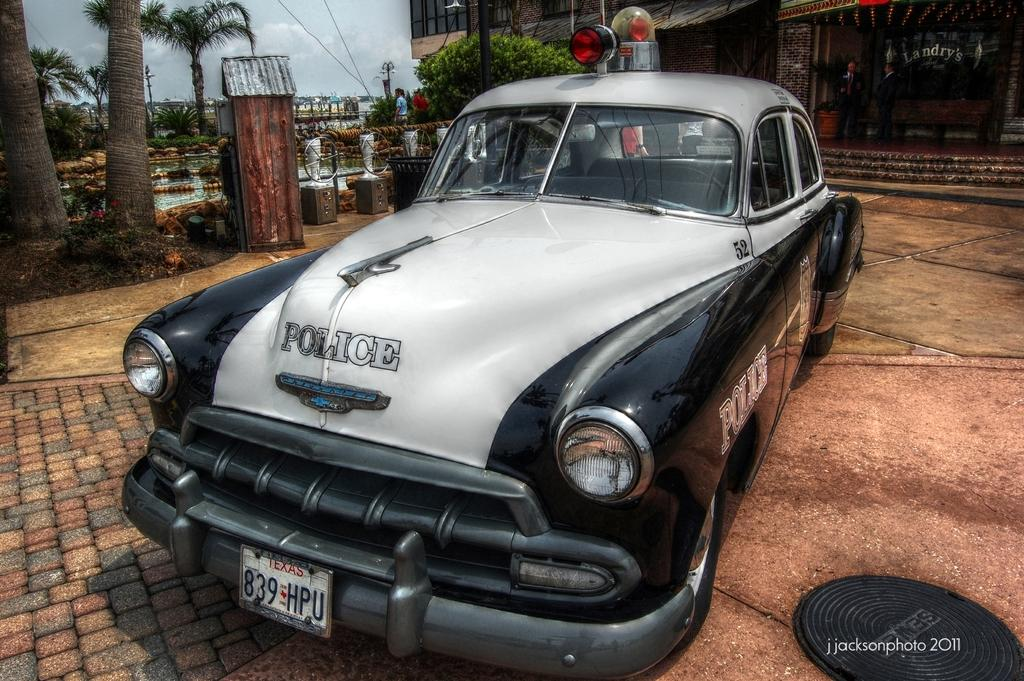What is the main subject in the foreground of the image? There is a police car in the foreground of the image. What is the position of the police car in the image? The police car is on the ground. What is located behind the police car in the image? There is a building behind the police car. What can be seen in the background of the image? Trees, water, a person, and the sky are visible in the background of the image. What type of bat is flying over the police car in the image? There is no bat present in the image; it only features a police car, a building, trees, water, a person, and the sky. 